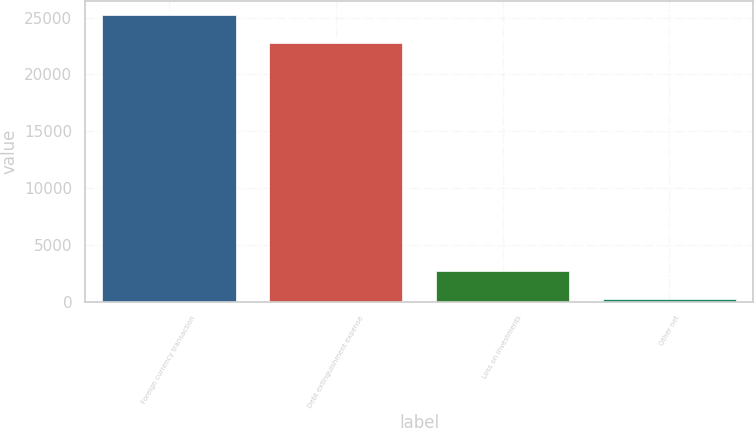Convert chart. <chart><loc_0><loc_0><loc_500><loc_500><bar_chart><fcel>Foreign currency transaction<fcel>Debt extinguishment expense<fcel>Loss on investments<fcel>Other net<nl><fcel>25240.1<fcel>22743<fcel>2701.1<fcel>204<nl></chart> 